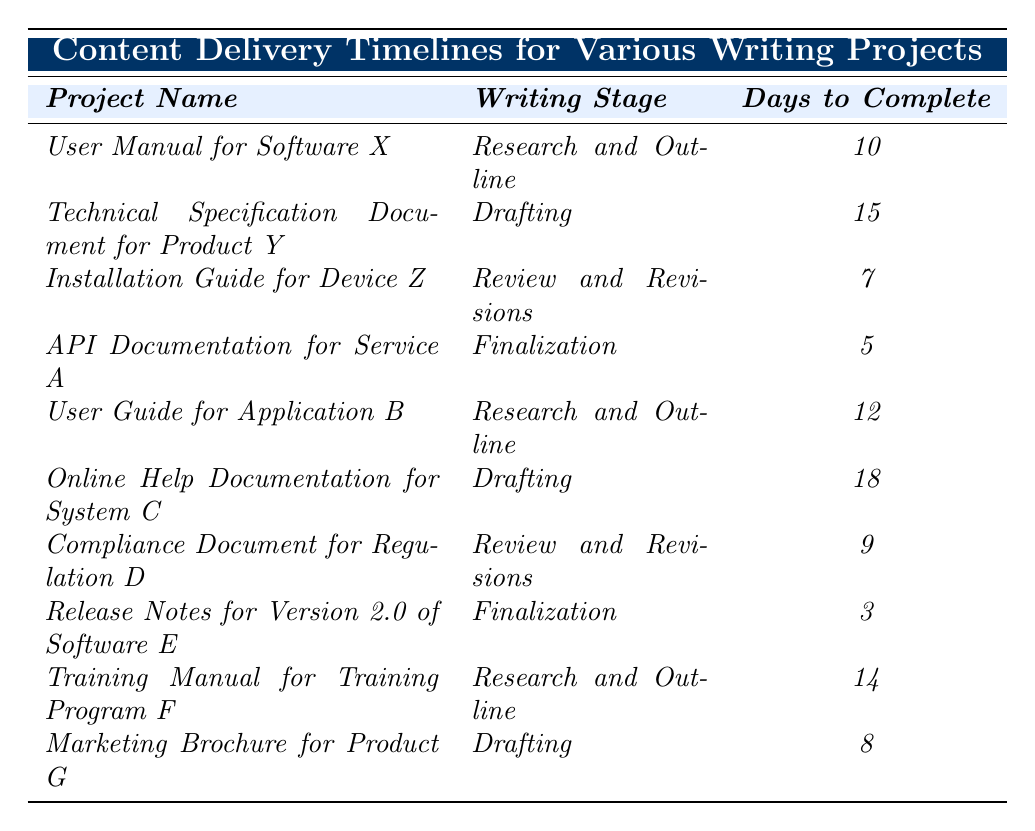What is the total number of days required to complete the *API Documentation for Service A*? The table indicates that the *API Documentation for Service A* has *5* days to complete.
Answer: 5 Which project has the longest writing stage duration in days? The project with the longest duration is the *Online Help Documentation for System C*, which takes *18* days to complete.
Answer: Online Help Documentation for System C How many projects are in the *Research and Outline* stage? There are three projects in the *Research and Outline* stage: *User Manual for Software X*, *User Guide for Application B*, and *Training Manual for Training Program F*.
Answer: 3 What is the average time required for projects in the *Finalization* stage? The projects in the *Finalization* stage are *API Documentation for Service A* (5 days) and *Release Notes for Version 2.0 of Software E* (3 days). The average is (5 + 3) / 2 = 4 days.
Answer: 4 Is the *Installation Guide for Device Z* completed faster than the *Compliance Document for Regulation D*? The *Installation Guide for Device Z* takes *7* days, and the *Compliance Document for Regulation D* takes *9* days. Since 7 is less than 9, the *Installation Guide for Device Z* is completed faster.
Answer: Yes What is the total time for all projects in the *Drafting* stage? The projects in the *Drafting* stage and their respective durations are *Technical Specification Document for Product Y* (15 days), *Online Help Documentation for System C* (18 days), and *Marketing Brochure for Product G* (8 days). Summing these gives 15 + 18 + 8 = 41 days.
Answer: 41 Which project has the second shortest writing stage duration? The project with the shortest duration is *Release Notes for Version 2.0 of Software E* at *3* days, and the second shortest is *API Documentation for Service A* at *5* days.
Answer: API Documentation for Service A How does the duration of *User Guide for Application B* compare to the overall average duration of all projects? The *User Guide for Application B* takes *12* days. To find the overall average, we sum all days (10 + 15 + 7 + 5 + 12 + 18 + 9 + 3 + 14 + 8 = 91) and divide by the number of projects (10). The average is 91 / 10 = 9.1 days. Since 12 is greater than 9.1, it takes longer than average.
Answer: Longer than average How many projects were completed in fewer than 10 days? The table shows *Release Notes for Version 2.0 of Software E* (3 days) and *API Documentation for Service A* (5 days). Therefore, there are *2* projects completed in fewer than 10 days.
Answer: 2 What is the difference in days between the longest and shortest projects? The longest project is *Online Help Documentation for System C* at *18* days, and the shortest project is *Release Notes for Version 2.0 of Software E* with *3* days. The difference is 18 - 3 = 15 days.
Answer: 15 